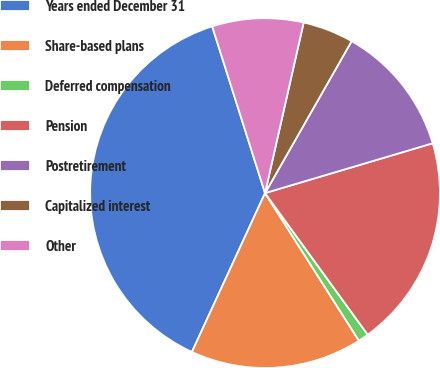<chart> <loc_0><loc_0><loc_500><loc_500><pie_chart><fcel>Years ended December 31<fcel>Share-based plans<fcel>Deferred compensation<fcel>Pension<fcel>Postretirement<fcel>Capitalized interest<fcel>Other<nl><fcel>38.25%<fcel>15.88%<fcel>0.97%<fcel>19.61%<fcel>12.16%<fcel>4.7%<fcel>8.43%<nl></chart> 